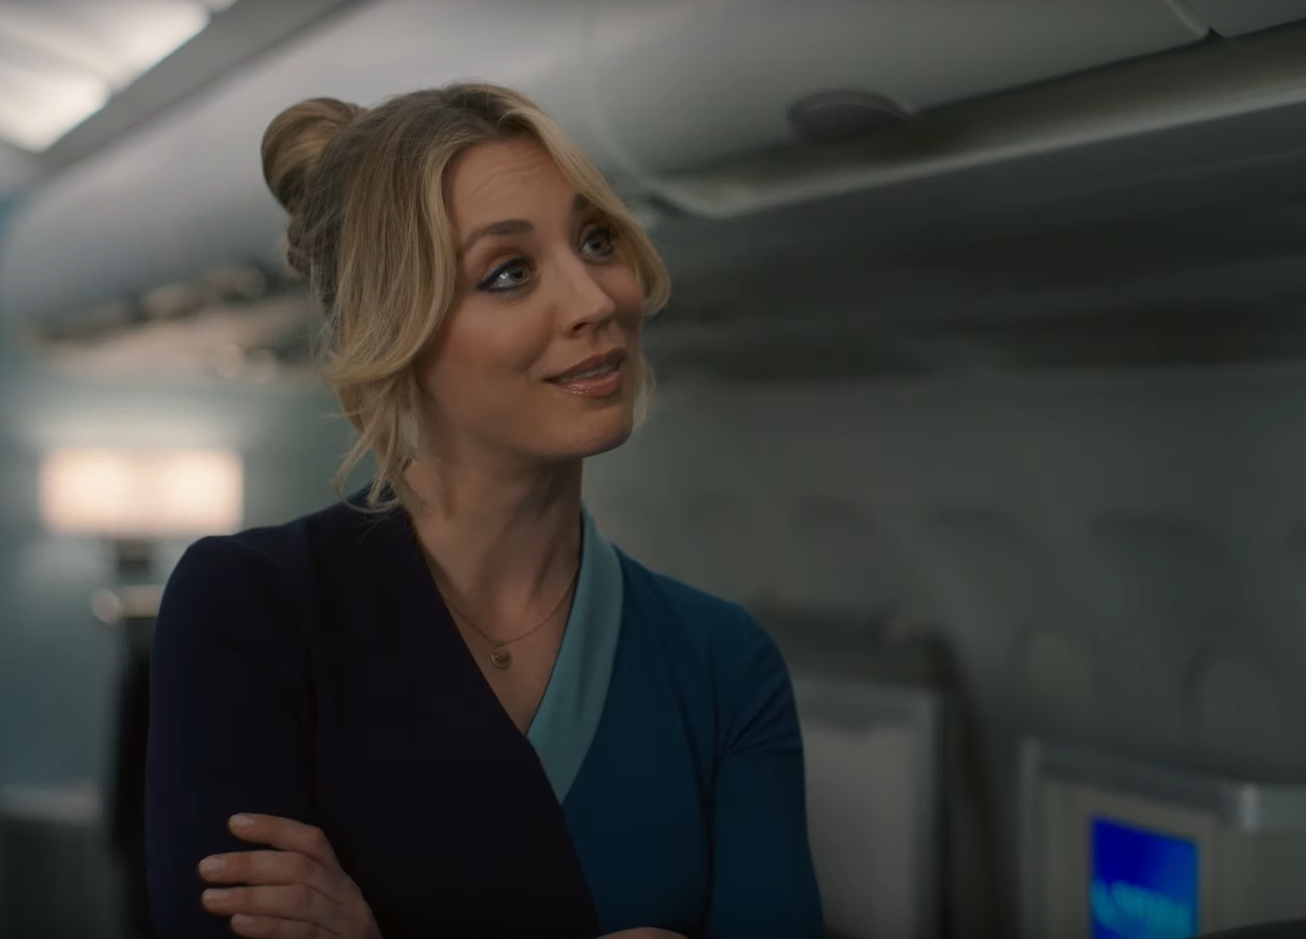Describe the atmosphere in the cabin as shown in the image. The cabin atmosphere exudes a tranquil and orderly vibe. The overhead compartments are closed, indicating preparedness for takeoff or having reached cruising altitude, and the seating area is free of clutter. The gentle lighting in the cabin adds to the sensation of calmness, providing a comfortable environment for passengers. The flight attendant's smile and relaxed demeanor further enhance the warm and welcoming feel of the airline service. 